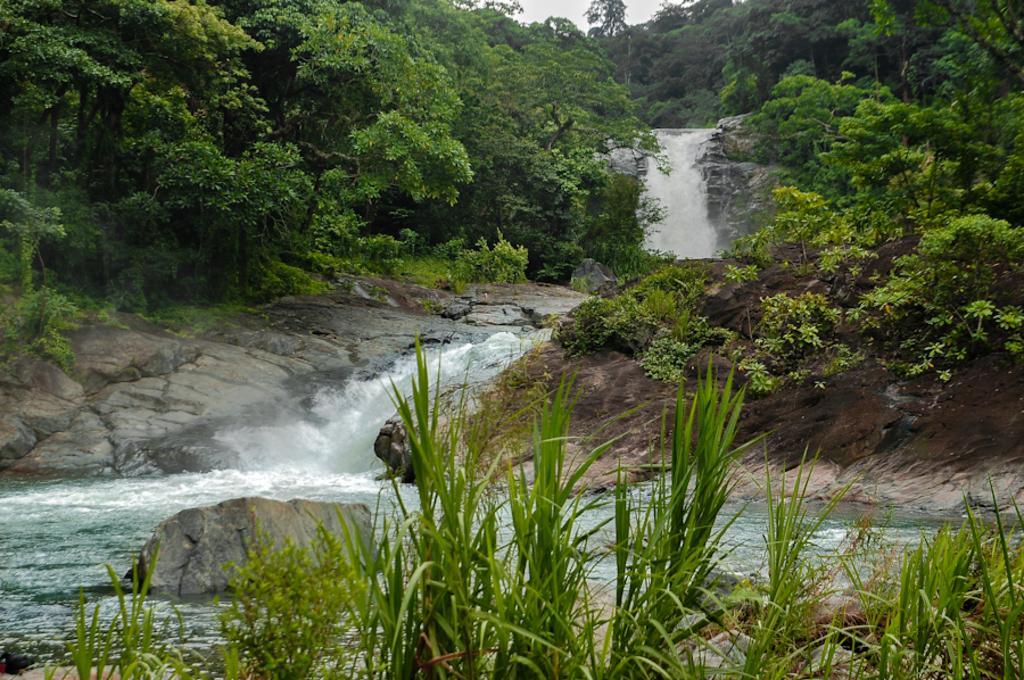Please provide a concise description of this image. In this image, we can see so many trees, rocks, waterfall, plants. Top of the image, there is a sky. 